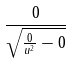<formula> <loc_0><loc_0><loc_500><loc_500>\frac { 0 } { \sqrt { \frac { 0 } { u ^ { 2 } } - 0 } }</formula> 